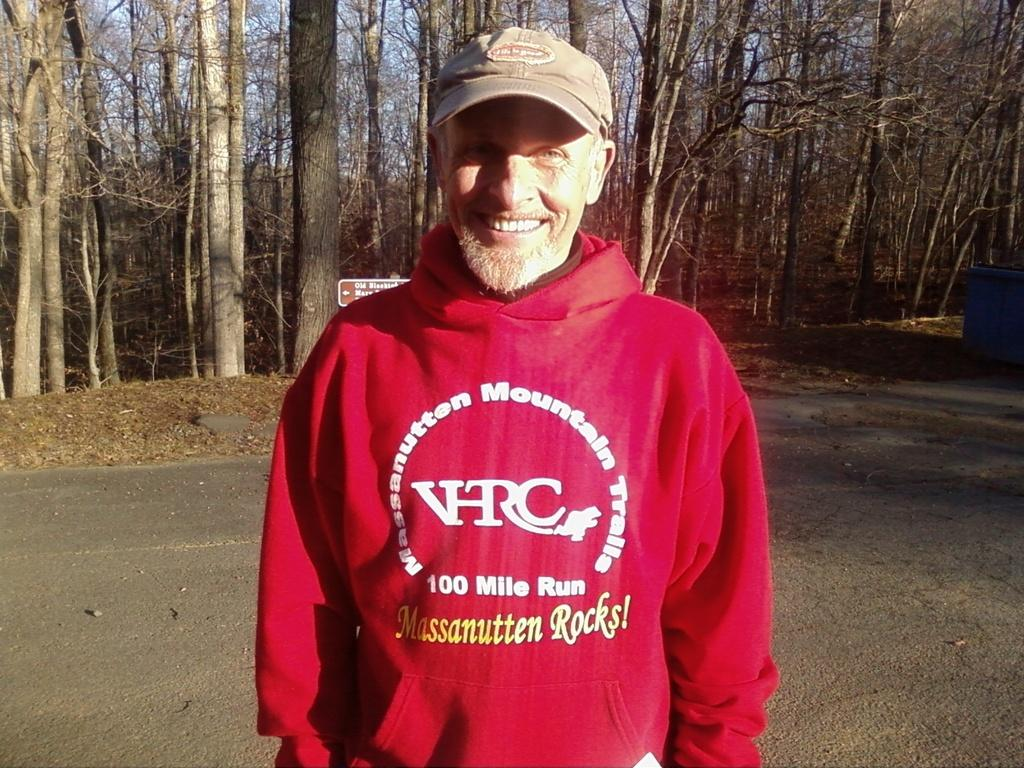<image>
Write a terse but informative summary of the picture. A man in a red sweater which is the words 100 mile run on it. 